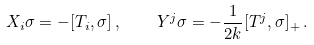Convert formula to latex. <formula><loc_0><loc_0><loc_500><loc_500>X _ { i } \sigma = - [ T _ { i } , \sigma ] \, , \quad Y ^ { j } \sigma = - \frac { 1 } { 2 k } [ T ^ { j } , \sigma ] _ { + } \, .</formula> 